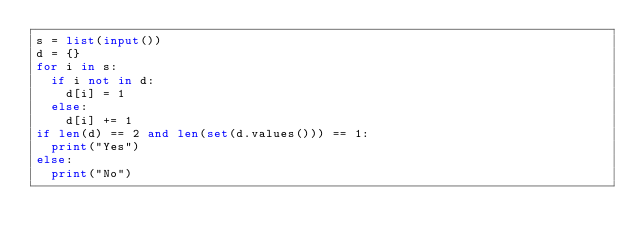<code> <loc_0><loc_0><loc_500><loc_500><_Python_>s = list(input())
d = {}
for i in s:
  if i not in d:
    d[i] = 1
  else:
    d[i] += 1
if len(d) == 2 and len(set(d.values())) == 1:
  print("Yes")
else:
  print("No")</code> 